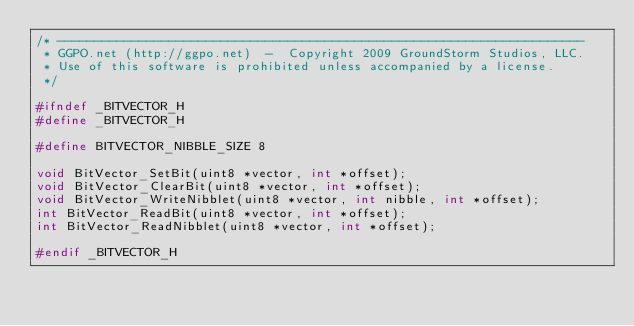Convert code to text. <code><loc_0><loc_0><loc_500><loc_500><_C_>/* -----------------------------------------------------------------------
 * GGPO.net (http://ggpo.net)  -  Copyright 2009 GroundStorm Studios, LLC.
 * Use of this software is prohibited unless accompanied by a license.
 */

#ifndef _BITVECTOR_H
#define _BITVECTOR_H

#define BITVECTOR_NIBBLE_SIZE 8

void BitVector_SetBit(uint8 *vector, int *offset);
void BitVector_ClearBit(uint8 *vector, int *offset);
void BitVector_WriteNibblet(uint8 *vector, int nibble, int *offset);
int BitVector_ReadBit(uint8 *vector, int *offset);
int BitVector_ReadNibblet(uint8 *vector, int *offset);

#endif _BITVECTOR_H
</code> 